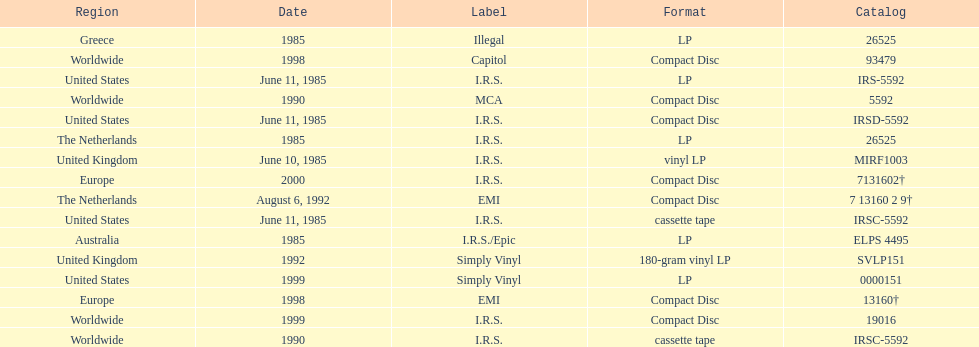What is the greatest consecutive amount of releases in lp format? 3. 